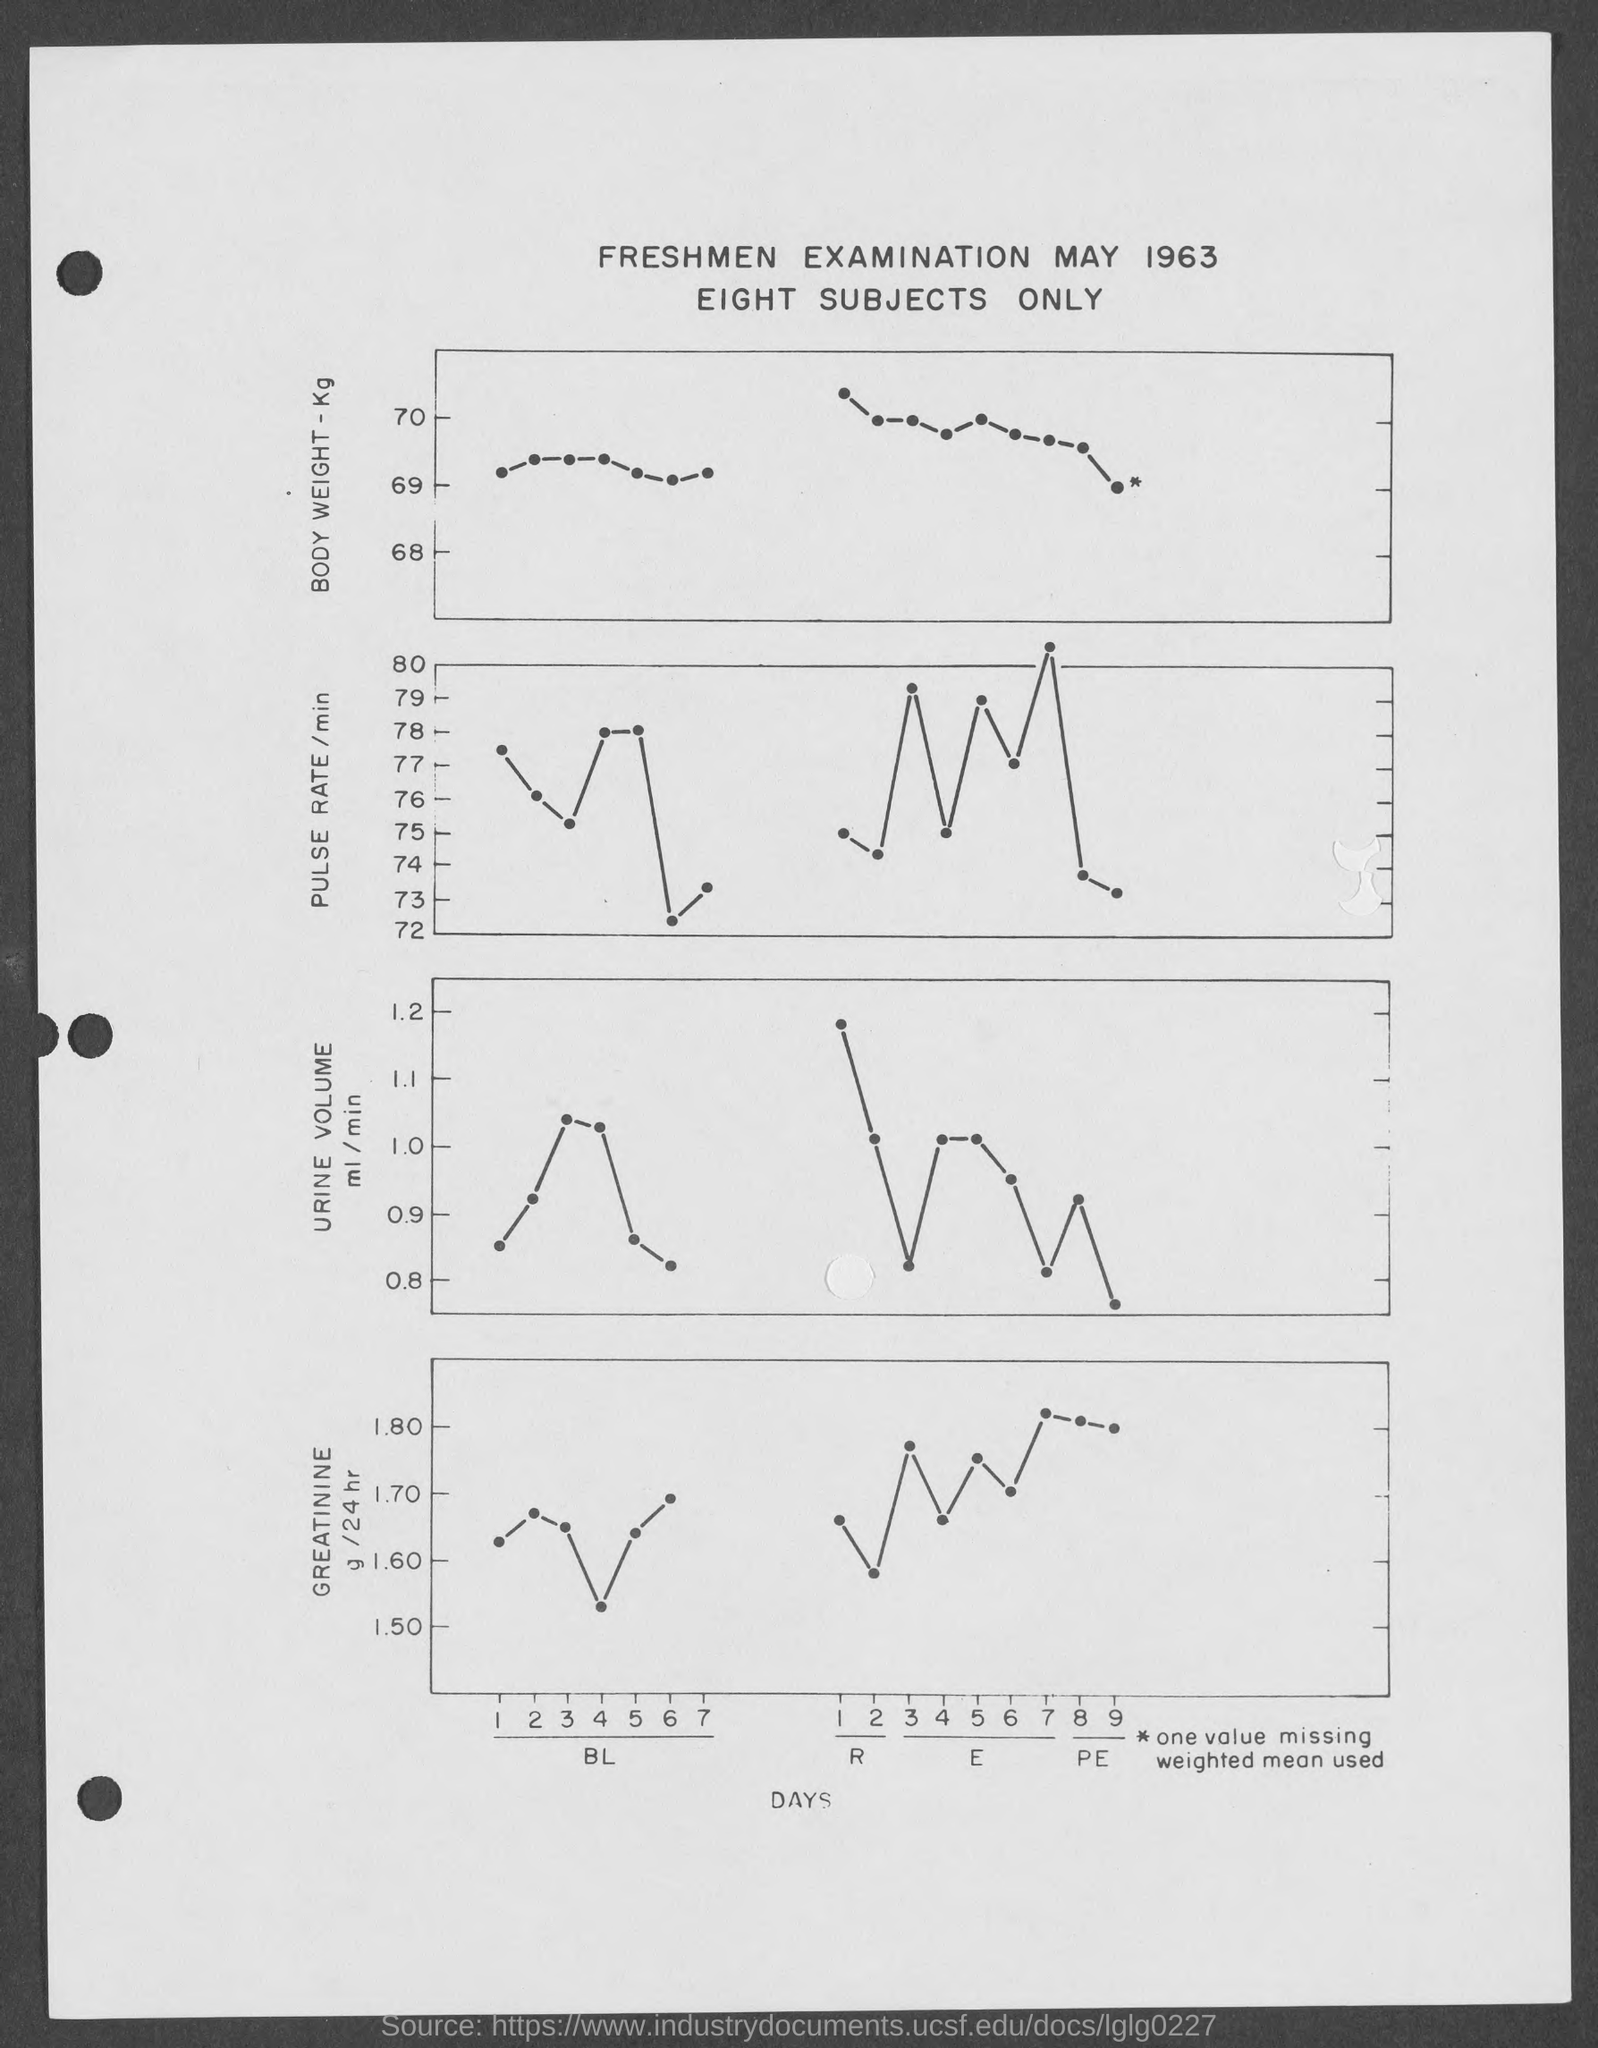Mention a couple of crucial points in this snapshot. The examination is of what year? 1963. The title of the examination is the Freshmen Examination, which took place on May 19, 1963. The y-axis in the first chart represents the body weight, measured in kilograms. 